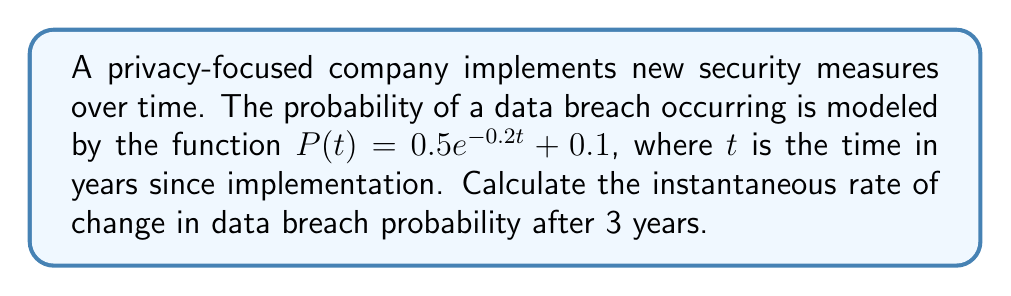Give your solution to this math problem. To find the instantaneous rate of change, we need to calculate the derivative of $P(t)$ and evaluate it at $t=3$.

Step 1: Calculate the derivative of $P(t)$.
$$\frac{d}{dt}P(t) = \frac{d}{dt}(0.5e^{-0.2t} + 0.1)$$
$$P'(t) = 0.5 \cdot (-0.2) \cdot e^{-0.2t} + 0$$
$$P'(t) = -0.1e^{-0.2t}$$

Step 2: Evaluate $P'(t)$ at $t=3$.
$$P'(3) = -0.1e^{-0.2(3)}$$
$$P'(3) = -0.1e^{-0.6}$$
$$P'(3) = -0.1 \cdot 0.5488116360940264$$
$$P'(3) \approx -0.05488116360940264$$

The negative value indicates that the probability of a data breach is decreasing over time.
Answer: $-0.05488$ per year 